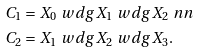<formula> <loc_0><loc_0><loc_500><loc_500>C _ { 1 } & = X _ { 0 } \ w d g X _ { 1 } \ w d g X _ { 2 } \ n n \\ C _ { 2 } & = X _ { 1 } \ w d g X _ { 2 } \ w d g X _ { 3 } .</formula> 